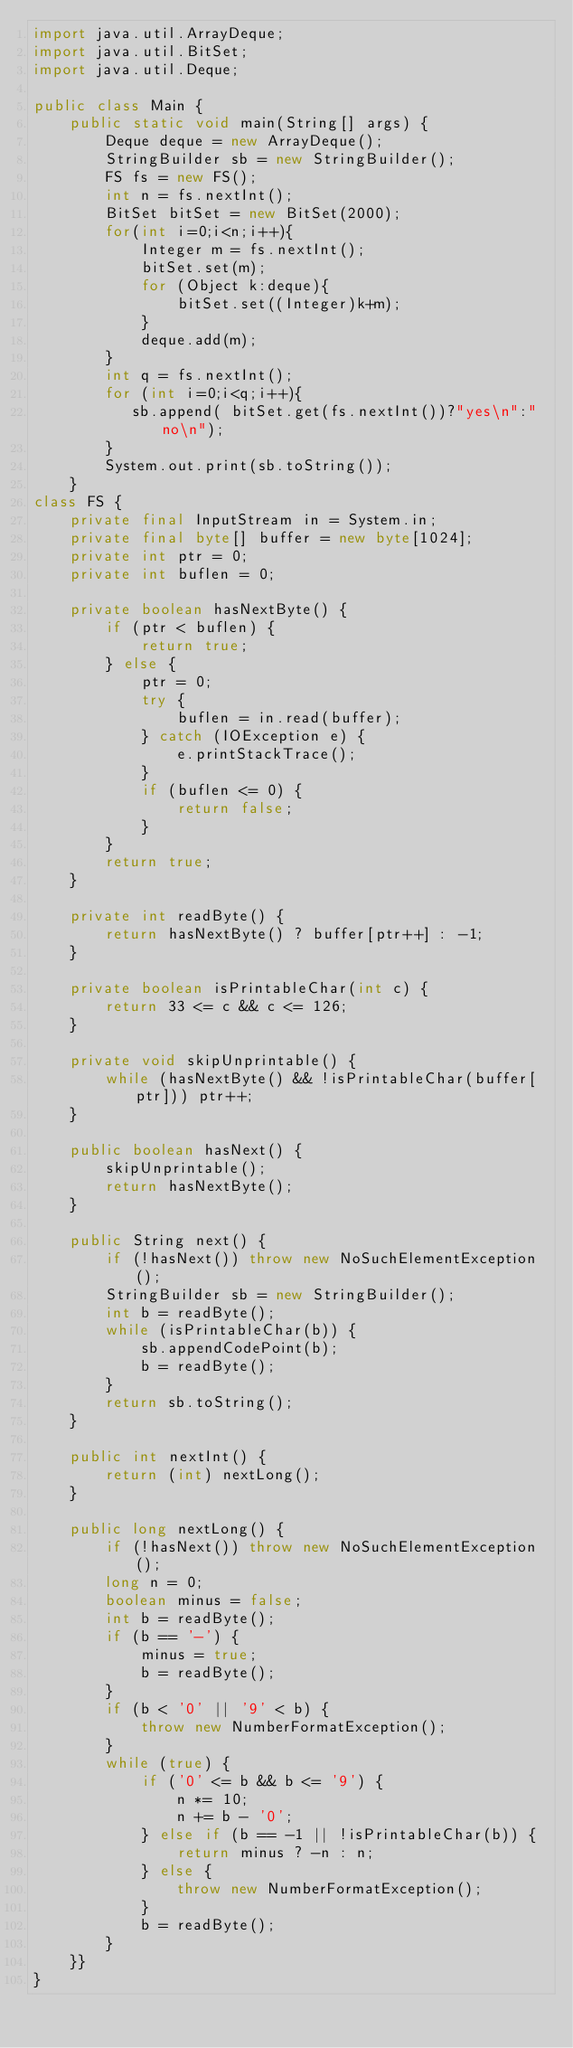<code> <loc_0><loc_0><loc_500><loc_500><_Java_>import java.util.ArrayDeque;
import java.util.BitSet;
import java.util.Deque;

public class Main {
    public static void main(String[] args) {
        Deque deque = new ArrayDeque();
        StringBuilder sb = new StringBuilder();
        FS fs = new FS();
        int n = fs.nextInt();
        BitSet bitSet = new BitSet(2000);
        for(int i=0;i<n;i++){
            Integer m = fs.nextInt();
            bitSet.set(m);
            for (Object k:deque){
                bitSet.set((Integer)k+m);
            }
            deque.add(m);
        }
        int q = fs.nextInt();
        for (int i=0;i<q;i++){
           sb.append( bitSet.get(fs.nextInt())?"yes\n":"no\n");
        }
        System.out.print(sb.toString());
    }
class FS {
    private final InputStream in = System.in;
    private final byte[] buffer = new byte[1024];
    private int ptr = 0;
    private int buflen = 0;

    private boolean hasNextByte() {
        if (ptr < buflen) {
            return true;
        } else {
            ptr = 0;
            try {
                buflen = in.read(buffer);
            } catch (IOException e) {
                e.printStackTrace();
            }
            if (buflen <= 0) {
                return false;
            }
        }
        return true;
    }

    private int readByte() {
        return hasNextByte() ? buffer[ptr++] : -1;
    }

    private boolean isPrintableChar(int c) {
        return 33 <= c && c <= 126;
    }

    private void skipUnprintable() {
        while (hasNextByte() && !isPrintableChar(buffer[ptr])) ptr++;
    }

    public boolean hasNext() {
        skipUnprintable();
        return hasNextByte();
    }

    public String next() {
        if (!hasNext()) throw new NoSuchElementException();
        StringBuilder sb = new StringBuilder();
        int b = readByte();
        while (isPrintableChar(b)) {
            sb.appendCodePoint(b);
            b = readByte();
        }
        return sb.toString();
    }

    public int nextInt() {
        return (int) nextLong();
    }

    public long nextLong() {
        if (!hasNext()) throw new NoSuchElementException();
        long n = 0;
        boolean minus = false;
        int b = readByte();
        if (b == '-') {
            minus = true;
            b = readByte();
        }
        if (b < '0' || '9' < b) {
            throw new NumberFormatException();
        }
        while (true) {
            if ('0' <= b && b <= '9') {
                n *= 10;
                n += b - '0';
            } else if (b == -1 || !isPrintableChar(b)) {
                return minus ? -n : n;
            } else {
                throw new NumberFormatException();
            }
            b = readByte();
        }
    }}
}
</code> 